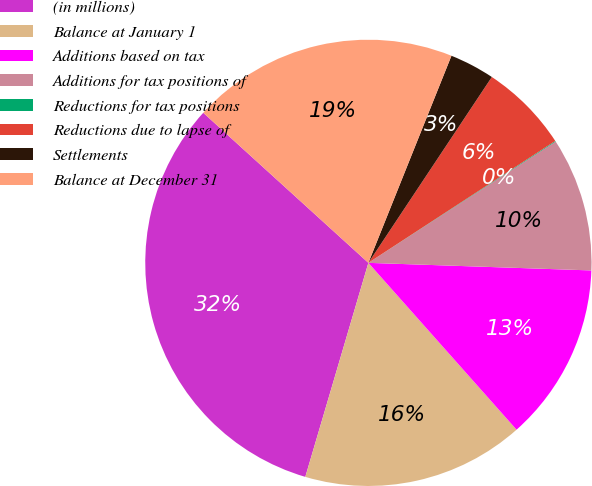<chart> <loc_0><loc_0><loc_500><loc_500><pie_chart><fcel>(in millions)<fcel>Balance at January 1<fcel>Additions based on tax<fcel>Additions for tax positions of<fcel>Reductions for tax positions<fcel>Reductions due to lapse of<fcel>Settlements<fcel>Balance at December 31<nl><fcel>32.18%<fcel>16.12%<fcel>12.9%<fcel>9.69%<fcel>0.05%<fcel>6.47%<fcel>3.26%<fcel>19.33%<nl></chart> 